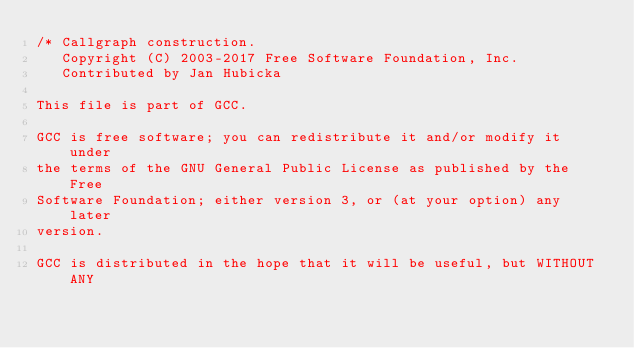<code> <loc_0><loc_0><loc_500><loc_500><_C_>/* Callgraph construction.
   Copyright (C) 2003-2017 Free Software Foundation, Inc.
   Contributed by Jan Hubicka

This file is part of GCC.

GCC is free software; you can redistribute it and/or modify it under
the terms of the GNU General Public License as published by the Free
Software Foundation; either version 3, or (at your option) any later
version.

GCC is distributed in the hope that it will be useful, but WITHOUT ANY</code> 